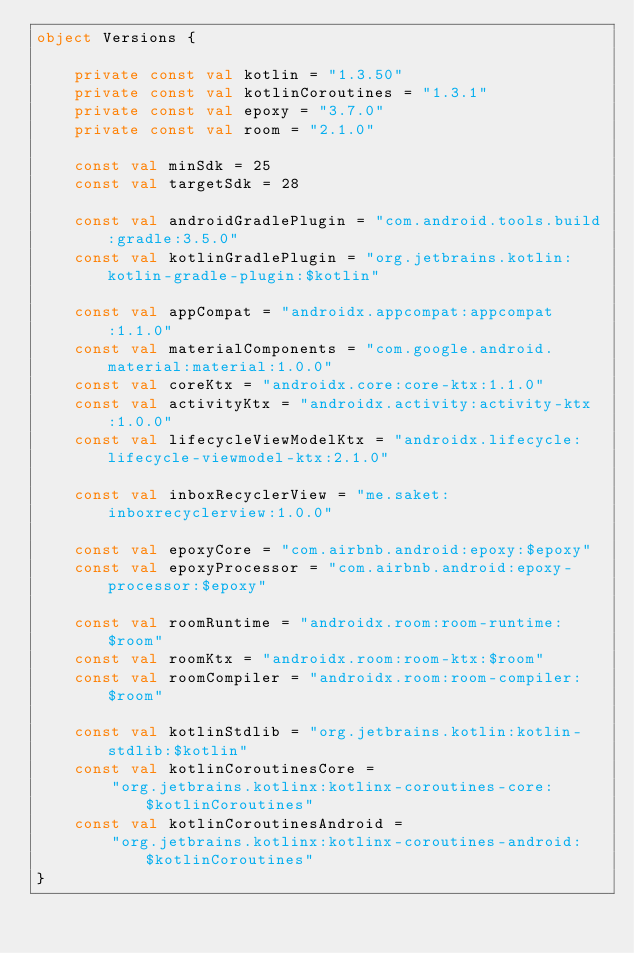<code> <loc_0><loc_0><loc_500><loc_500><_Kotlin_>object Versions {

    private const val kotlin = "1.3.50"
    private const val kotlinCoroutines = "1.3.1"
    private const val epoxy = "3.7.0"
    private const val room = "2.1.0"

    const val minSdk = 25
    const val targetSdk = 28

    const val androidGradlePlugin = "com.android.tools.build:gradle:3.5.0"
    const val kotlinGradlePlugin = "org.jetbrains.kotlin:kotlin-gradle-plugin:$kotlin"

    const val appCompat = "androidx.appcompat:appcompat:1.1.0"
    const val materialComponents = "com.google.android.material:material:1.0.0"
    const val coreKtx = "androidx.core:core-ktx:1.1.0"
    const val activityKtx = "androidx.activity:activity-ktx:1.0.0"
    const val lifecycleViewModelKtx = "androidx.lifecycle:lifecycle-viewmodel-ktx:2.1.0"

    const val inboxRecyclerView = "me.saket:inboxrecyclerview:1.0.0"

    const val epoxyCore = "com.airbnb.android:epoxy:$epoxy"
    const val epoxyProcessor = "com.airbnb.android:epoxy-processor:$epoxy"

    const val roomRuntime = "androidx.room:room-runtime:$room"
    const val roomKtx = "androidx.room:room-ktx:$room"
    const val roomCompiler = "androidx.room:room-compiler:$room"

    const val kotlinStdlib = "org.jetbrains.kotlin:kotlin-stdlib:$kotlin"
    const val kotlinCoroutinesCore =
        "org.jetbrains.kotlinx:kotlinx-coroutines-core:$kotlinCoroutines"
    const val kotlinCoroutinesAndroid =
        "org.jetbrains.kotlinx:kotlinx-coroutines-android:$kotlinCoroutines"
}
</code> 